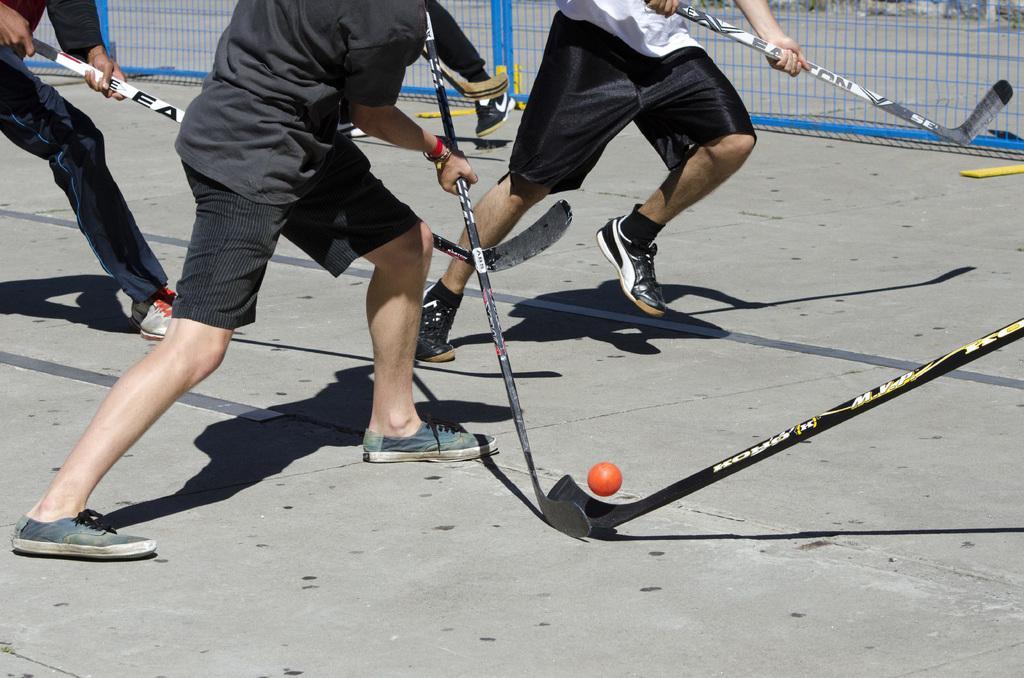Please provide a concise description of this image. In this image, we can see persons holding sticks and playing hockey. There is a ball at the bottom of the image. There is a mesh at the top of the image. 